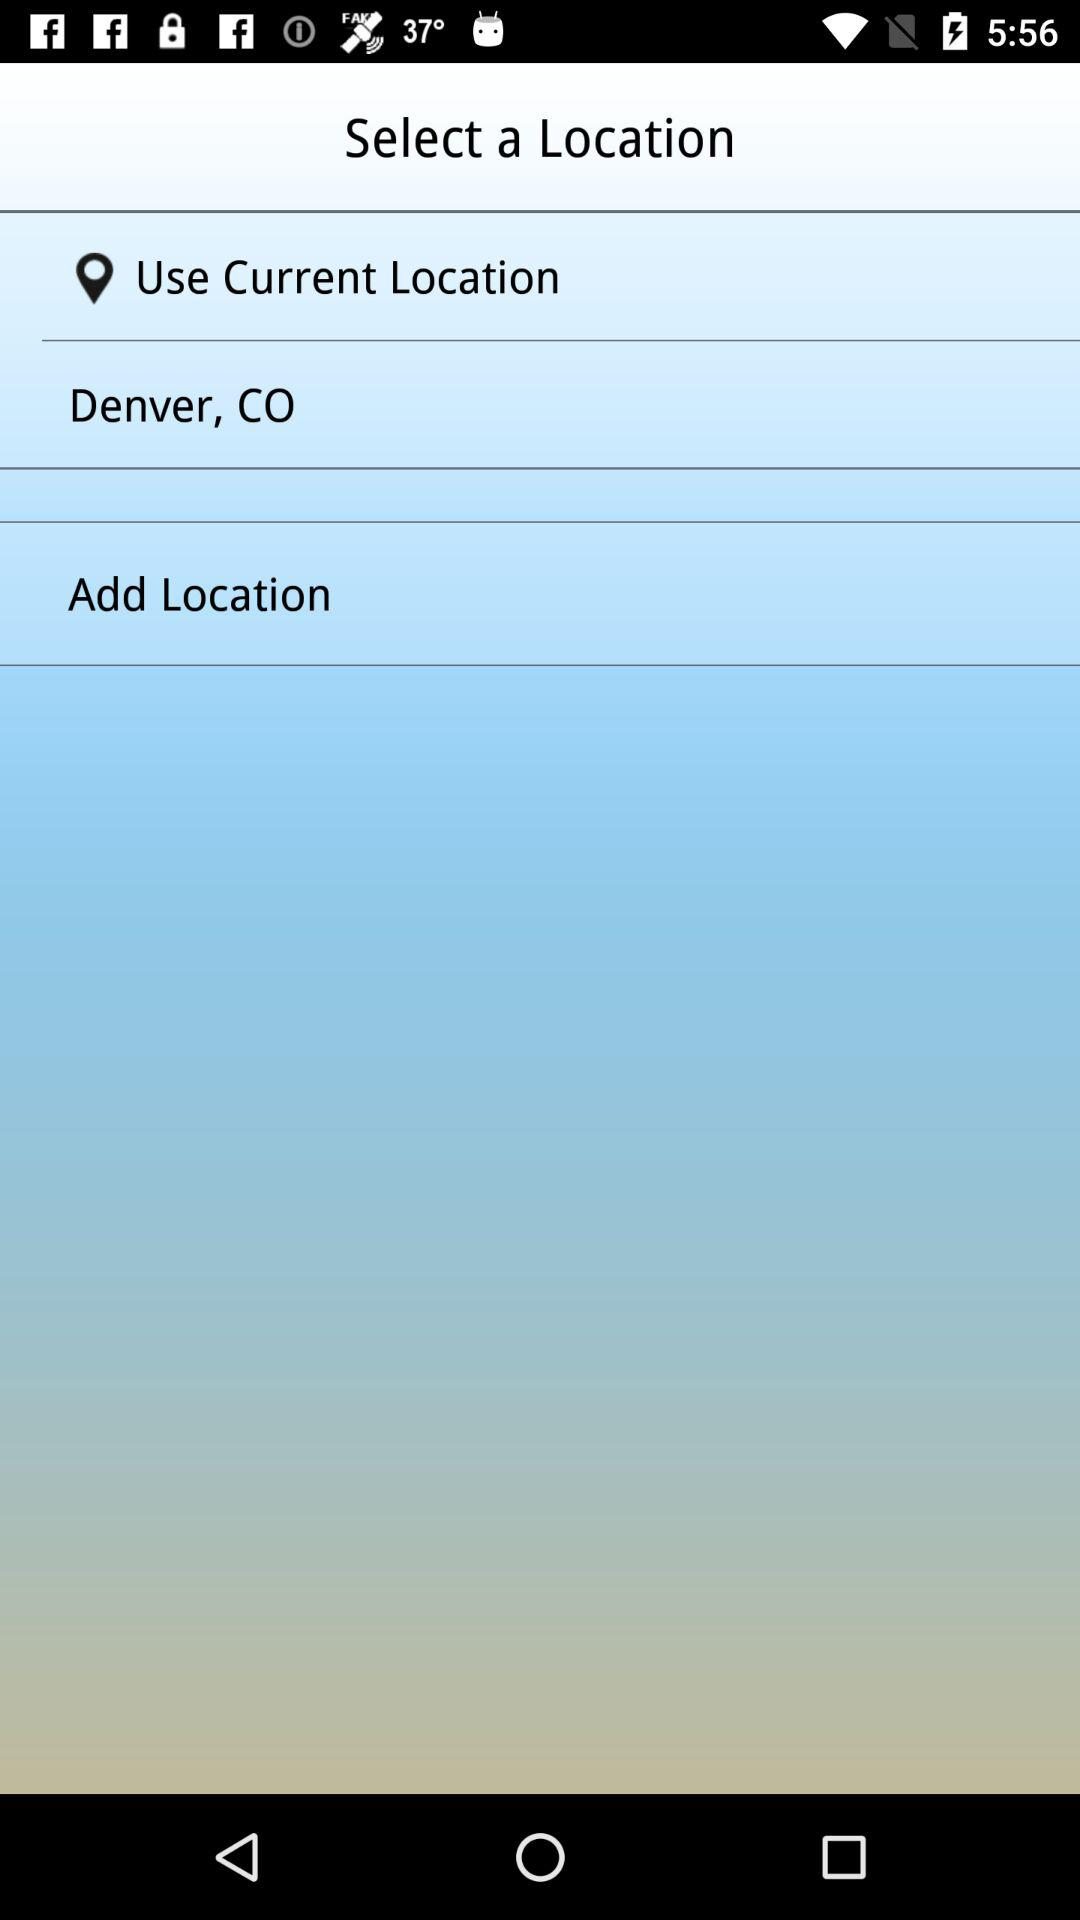How many locations are available to select from?
Answer the question using a single word or phrase. 2 